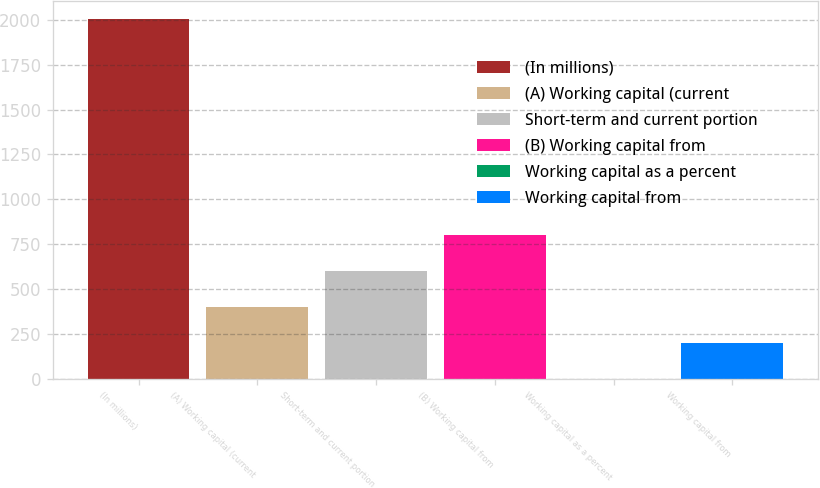Convert chart to OTSL. <chart><loc_0><loc_0><loc_500><loc_500><bar_chart><fcel>(In millions)<fcel>(A) Working capital (current<fcel>Short-term and current portion<fcel>(B) Working capital from<fcel>Working capital as a percent<fcel>Working capital from<nl><fcel>2005<fcel>401.48<fcel>601.92<fcel>802.36<fcel>0.6<fcel>201.04<nl></chart> 